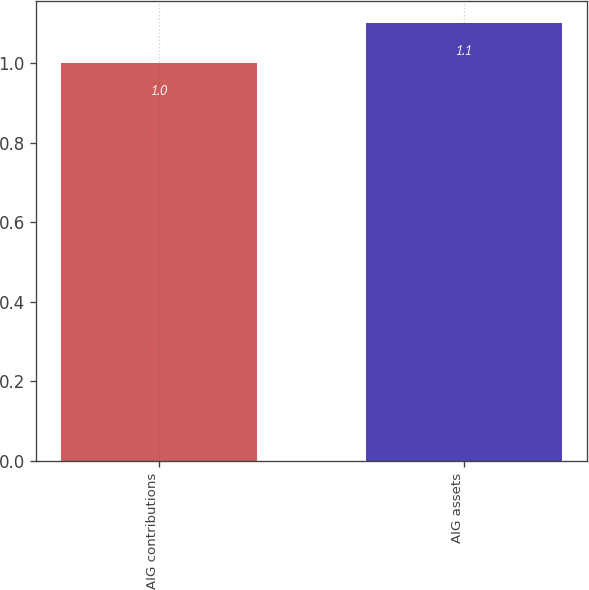Convert chart. <chart><loc_0><loc_0><loc_500><loc_500><bar_chart><fcel>AIG contributions<fcel>AIG assets<nl><fcel>1<fcel>1.1<nl></chart> 